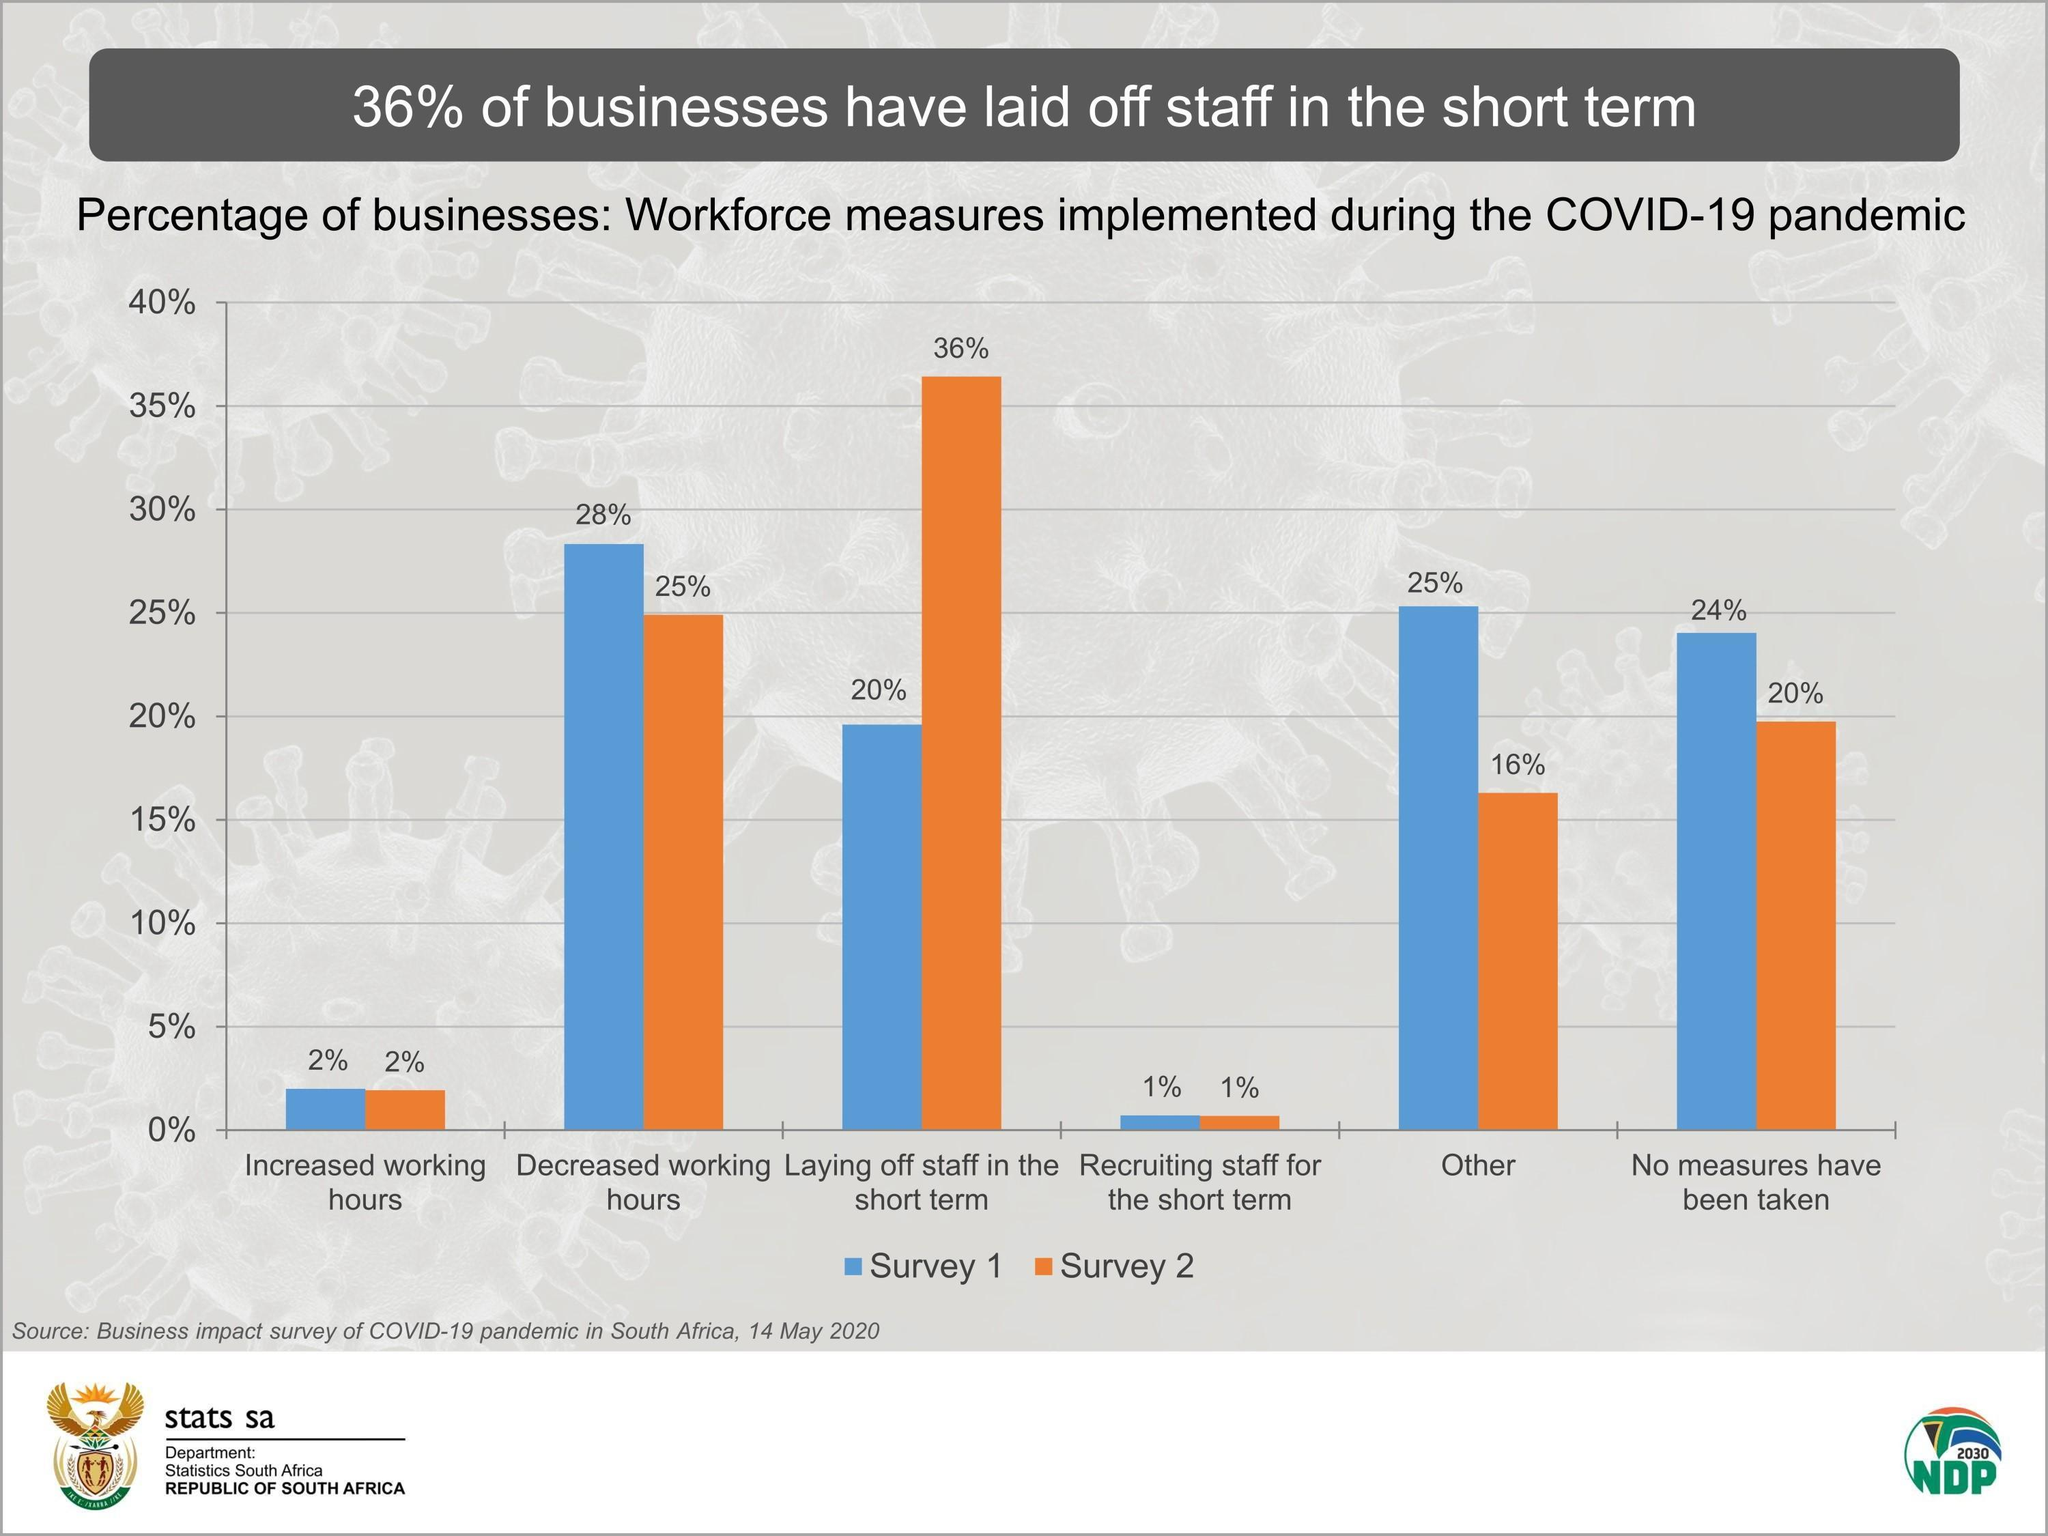What is the percentage of "other" in survey one and survey two?
Answer the question with a short phrase. 41% What is the percentage of increased working hours in survey one and survey two, taken together? 4% What is the percentage of decreased working hours and increased working hours in survey 1, taken together? 30% What is the percentage of recruiting staff for the short term in survey one and survey two, taken together? 2% 